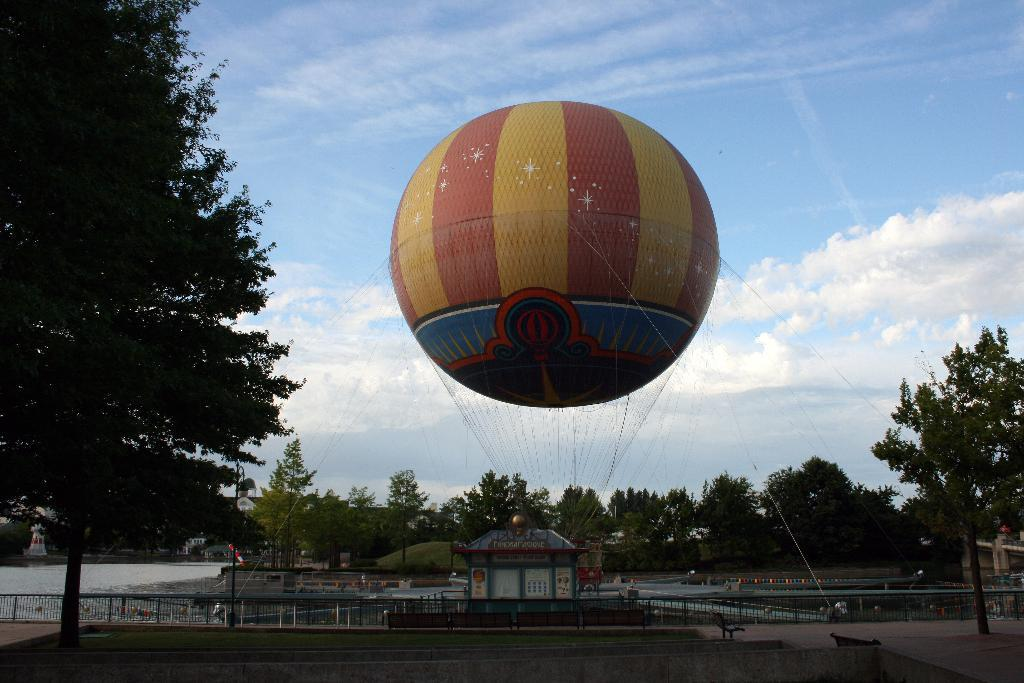What is the main object in the image? There is a giant helium balloon in the image. What is attached to the balloon? The balloon has threads. What type of structure can be seen in the image? There is a building in the image. What type of seating is available in the image? There are benches in the image. What type of vegetation is present in the image? Plants and trees are visible in the image. What type of surface can be seen in the image? There is water in the image. What type of barrier is present in the image? Iron grills are present in the image. What part of the natural environment is visible in the image? The sky is visible in the image. What type of government system is being discussed in the image? There is no discussion of a government system in the image; it features a giant helium balloon and other related elements. Can you see a boat in the image? There is no boat present in the image. 